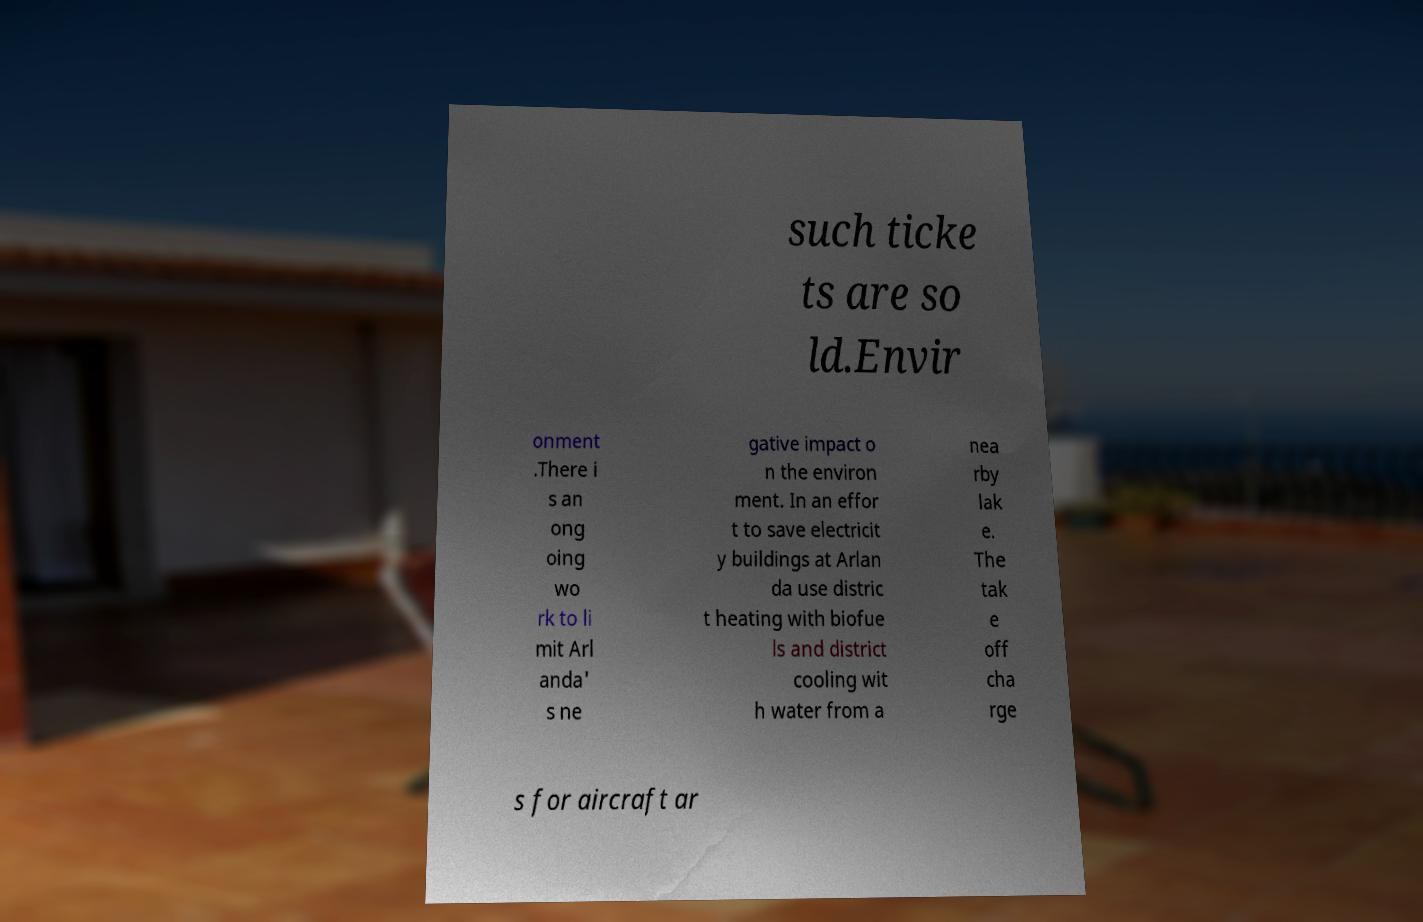Could you extract and type out the text from this image? such ticke ts are so ld.Envir onment .There i s an ong oing wo rk to li mit Arl anda' s ne gative impact o n the environ ment. In an effor t to save electricit y buildings at Arlan da use distric t heating with biofue ls and district cooling wit h water from a nea rby lak e. The tak e off cha rge s for aircraft ar 